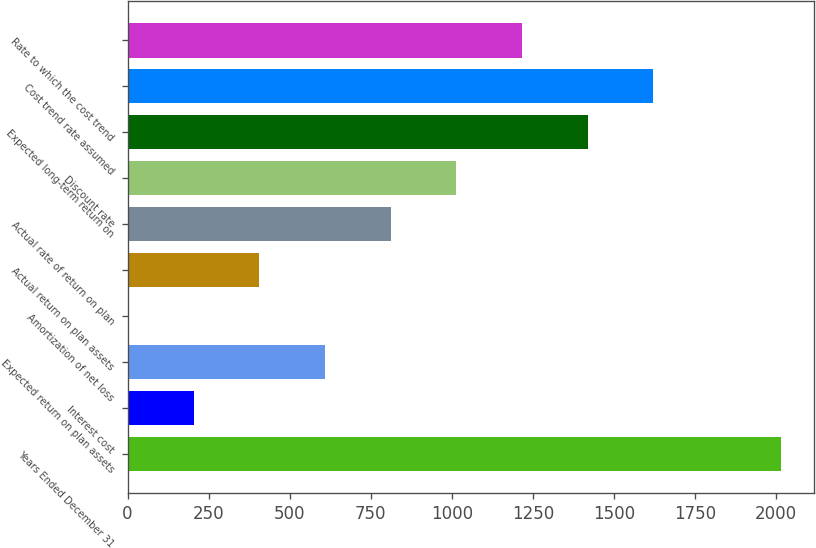Convert chart to OTSL. <chart><loc_0><loc_0><loc_500><loc_500><bar_chart><fcel>Years Ended December 31<fcel>Interest cost<fcel>Expected return on plan assets<fcel>Amortization of net loss<fcel>Actual return on plan assets<fcel>Actual rate of return on plan<fcel>Discount rate<fcel>Expected long-term return on<fcel>Cost trend rate assumed<fcel>Rate to which the cost trend<nl><fcel>2017<fcel>203.6<fcel>608.8<fcel>1<fcel>406.2<fcel>811.4<fcel>1014<fcel>1419.2<fcel>1621.8<fcel>1216.6<nl></chart> 